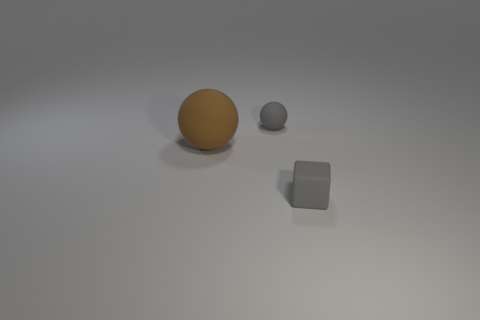Are there any signs of wear or damage on the objects? There are no visible signs of wear, damage, or imperfections on any of the objects; they appear to be pristine. 